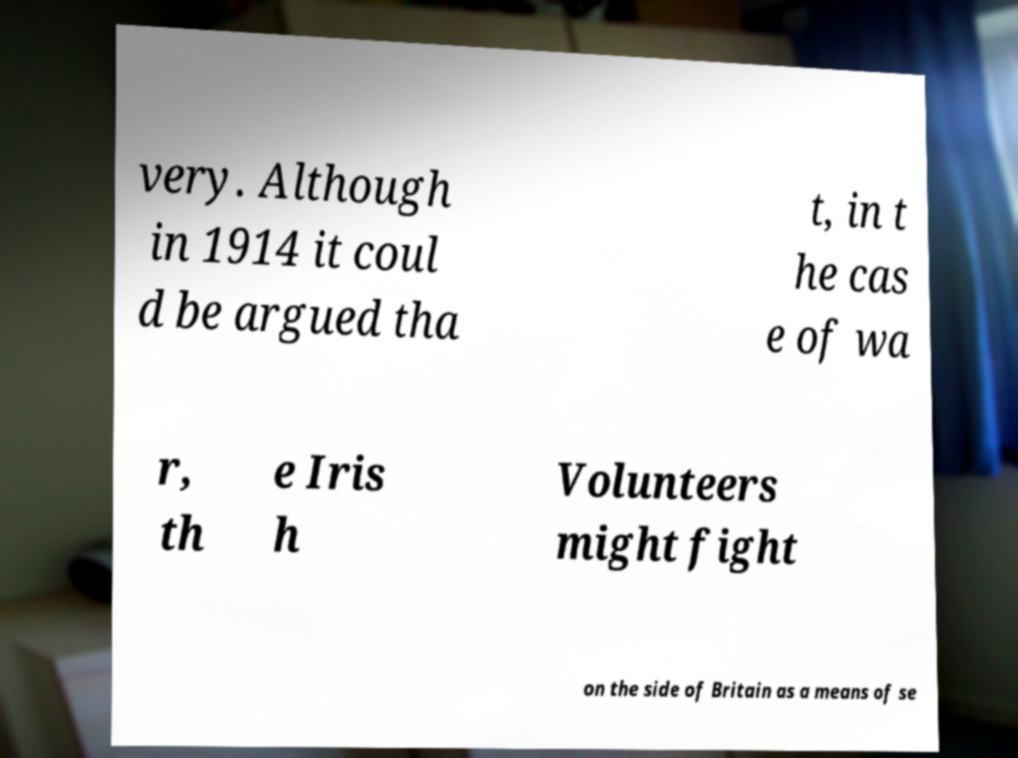I need the written content from this picture converted into text. Can you do that? very. Although in 1914 it coul d be argued tha t, in t he cas e of wa r, th e Iris h Volunteers might fight on the side of Britain as a means of se 